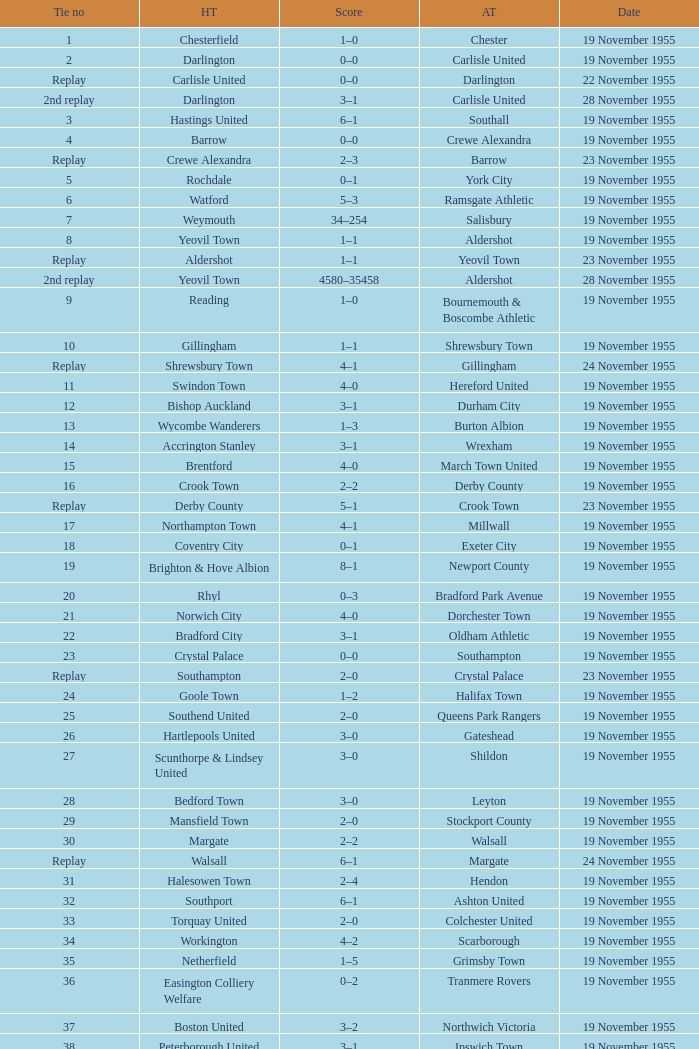What is the date of tie no. 34? 19 November 1955. 